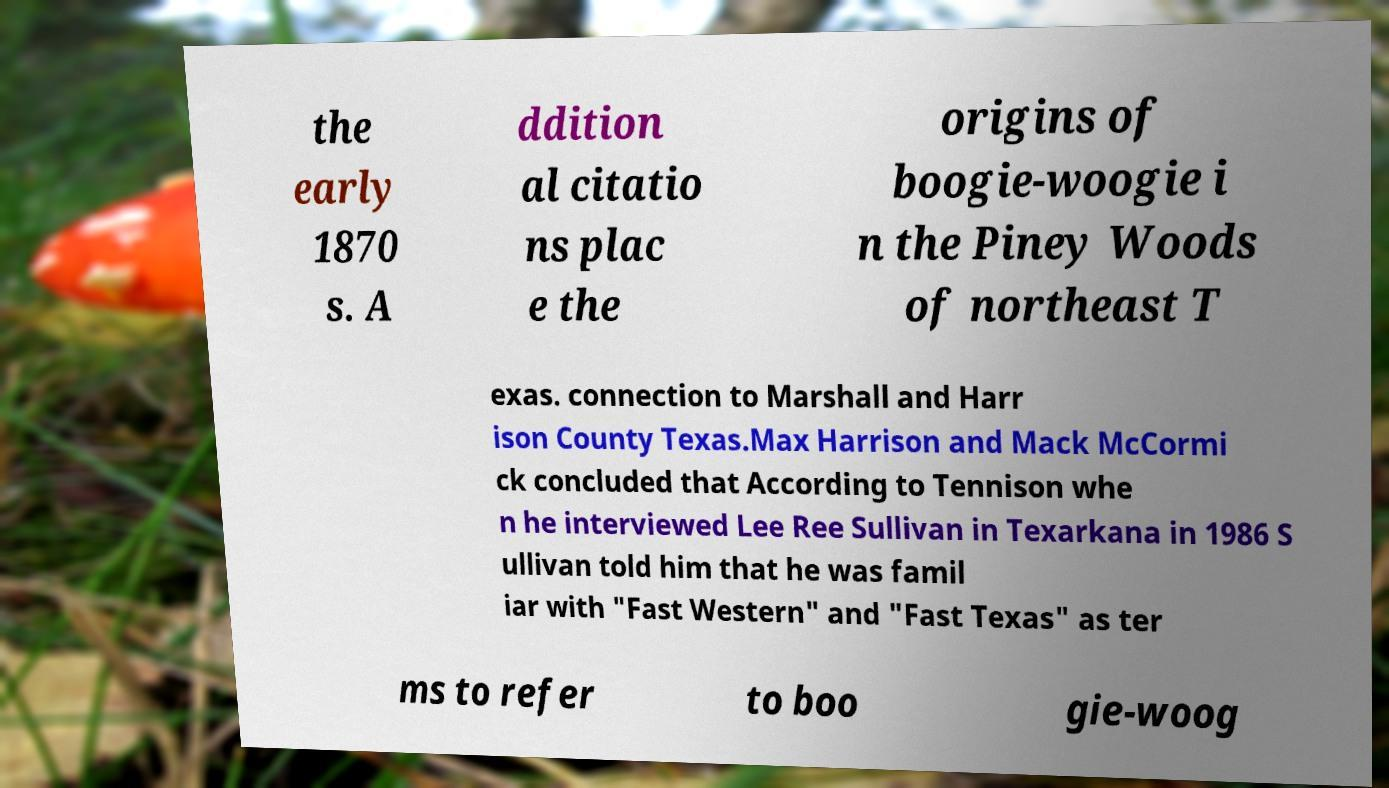Please read and relay the text visible in this image. What does it say? the early 1870 s. A ddition al citatio ns plac e the origins of boogie-woogie i n the Piney Woods of northeast T exas. connection to Marshall and Harr ison County Texas.Max Harrison and Mack McCormi ck concluded that According to Tennison whe n he interviewed Lee Ree Sullivan in Texarkana in 1986 S ullivan told him that he was famil iar with "Fast Western" and "Fast Texas" as ter ms to refer to boo gie-woog 